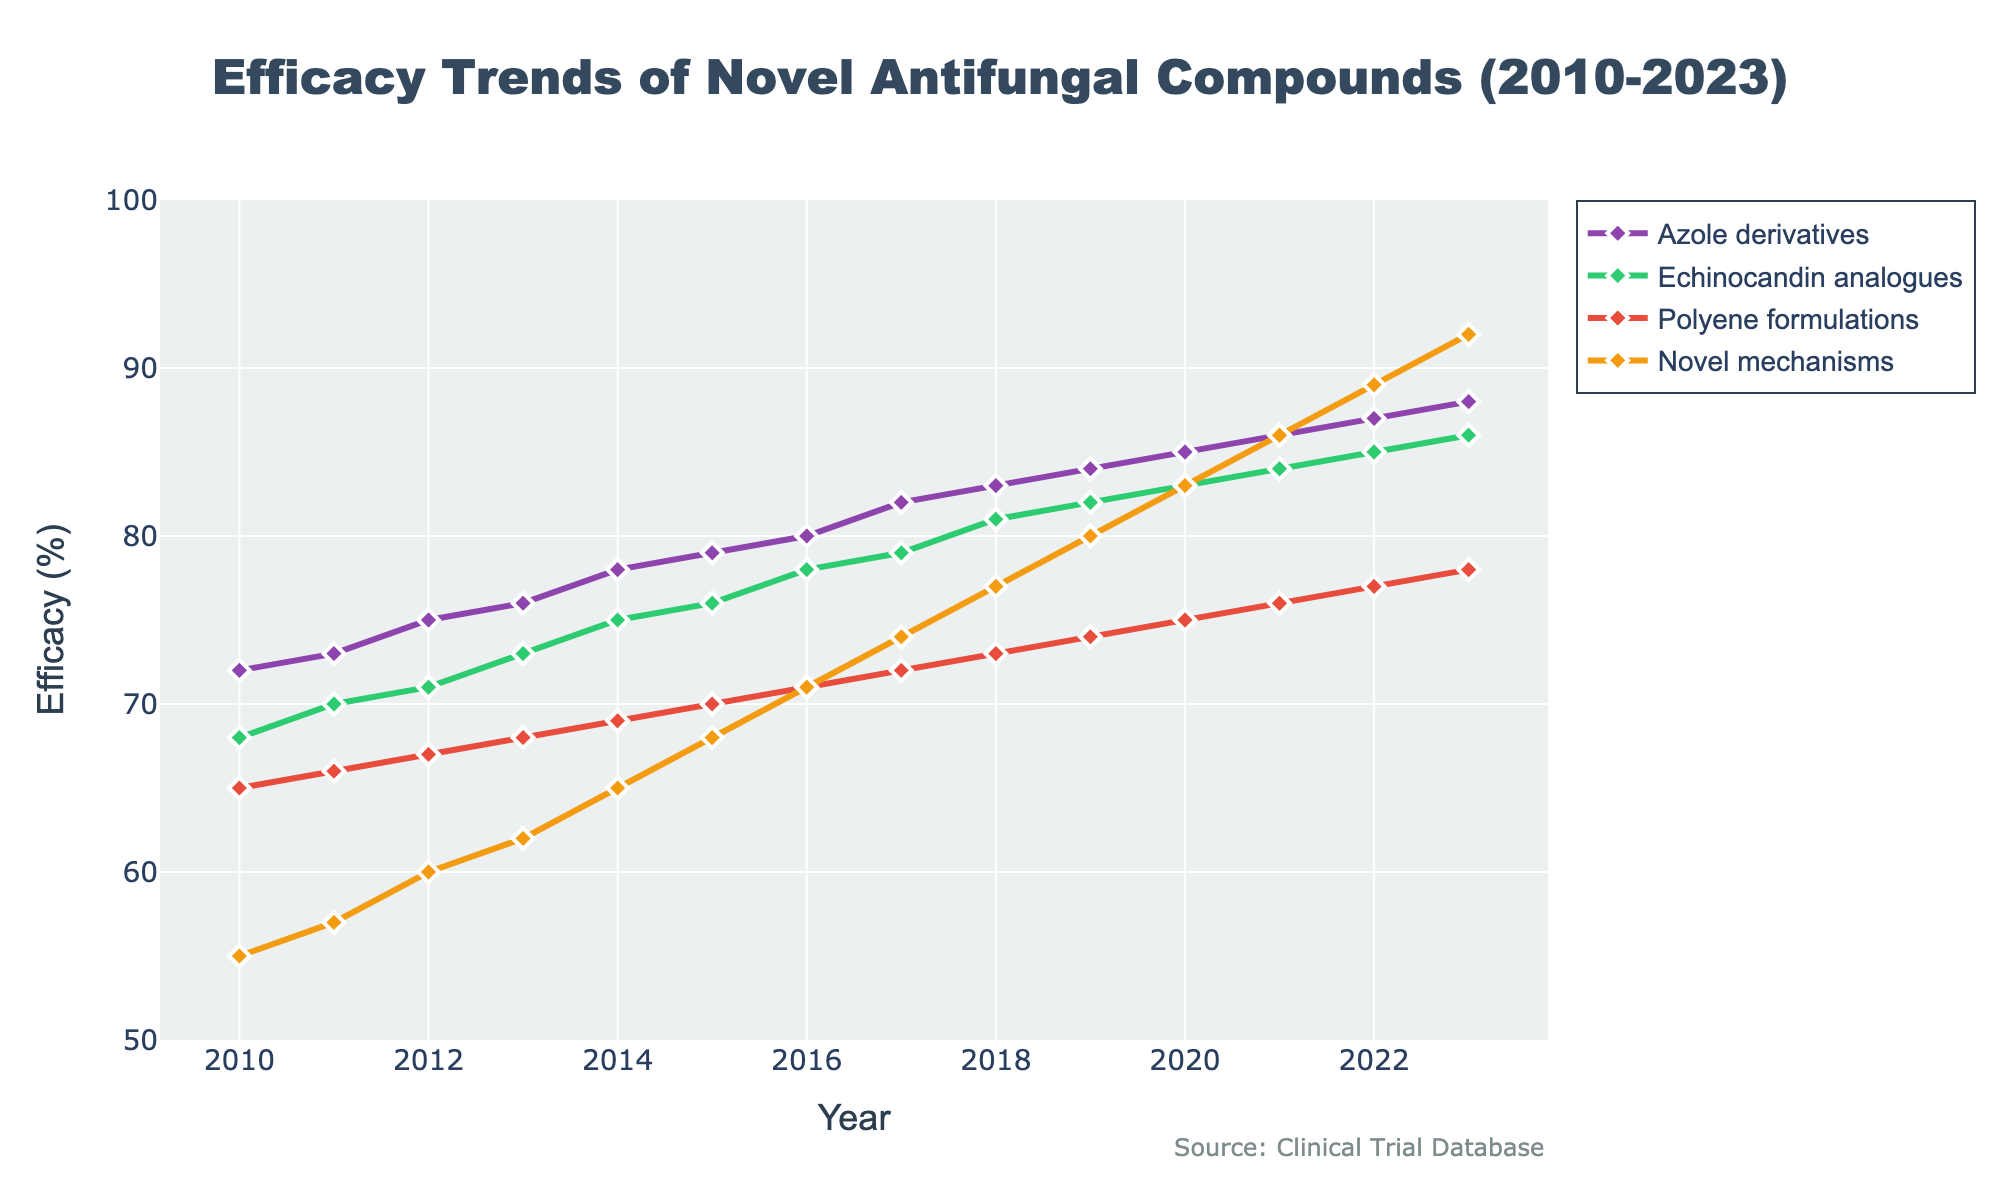What is the efficacy trend for Azole derivatives from 2010 to 2023? To identify the trend, observe the line representing Azole derivatives from 2010 to 2023. The line shows an upward trajectory, starting at 72% in 2010 and steadily increasing to 88% in 2023. Therefore, the trend is an increase in efficacy.
Answer: Increasing Which antifungal compound had the highest efficacy in 2023? To determine the highest efficacy in 2023, compare the endpoints of all lines for that year. The line for Novel mechanisms ends at 92%, which is the highest value among the four compounds for 2023.
Answer: Novel mechanisms How much did the efficacy of Echinocandin analogues increase from 2015 to 2023? Identify the efficacy values for Echinocandin analogues in 2015 and 2023, which are 76% and 86%, respectively. To find the increase, subtract the 2015 value from the 2023 value: 86% - 76% = 10%.
Answer: 10% Between which years did the Polyene formulations show the most significant improvement in efficacy? Observe the Polyene formulations line and evaluate the slope between each year. The steepest increase appears between 2012 and 2013, where the efficacy rises from 67% to 68%. While the difference is small, it is consistent with the overall trend.
Answer: 2012-2013 What is the difference in efficacy between the highest and lowest compound in 2018? Examine the efficacy values for all compounds in 2018: Azole derivatives (83%), Echinocandin analogues (81%), Polyene formulations (73%), and Novel mechanisms (77%). The difference between the highest (Azole derivatives at 83%) and the lowest (Polyene formulations at 73%) is 83% - 73% = 10%.
Answer: 10% Which antifungal compound had the least improvement in efficacy over the designated period, and what was the improvement? To find the least improvement, compute the difference between 2023 and 2010 values for all compounds: Azole derivatives (88%-72% = 16%), Echinocandin analogues (86%-68% = 18%), Polyene formulations (78%-65% = 13%), and Novel mechanisms (92%-55% = 37%). The least improvement was in Polyene formulations with 13%.
Answer: Polyene formulations, 13% What is the average efficacy of Novel mechanisms between 2010 and 2023? Calculate the average by summing the efficacy values of Novel mechanisms for each year from 2010 to 2023 and then dividing by the number of years (14). The sum is 55 + 57 + 60 + 62 + 65 + 68 + 71 + 74 + 77 + 80 + 83 + 86 + 89 + 92 = 1019; the average is 1019 / 14 = 72.79%.
Answer: 72.79% During which period did the efficacy of Azole derivatives show the steepest annual increase? To find the steepest increase, calculate the annual changes in efficacy for Azole derivatives and identify the maximum change. The most significant increase is between 2010 and 2011, where the efficacy rose by 1% (73% - 72%). This period had a steady but relatively steep pace of improvement.
Answer: 2010-2011 Which antifungal compound showed a consistent linear increase in efficacy over the period, and how can this be identified visually? To identify a consistent linear increase, observe the visual linearity of the lines. Azole derivatives display a consistent and almost straight ascending line, indicating a steady increase in efficacy over time.
Answer: Azole derivatives 